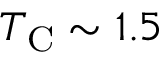Convert formula to latex. <formula><loc_0><loc_0><loc_500><loc_500>T _ { C } \sim 1 . 5</formula> 